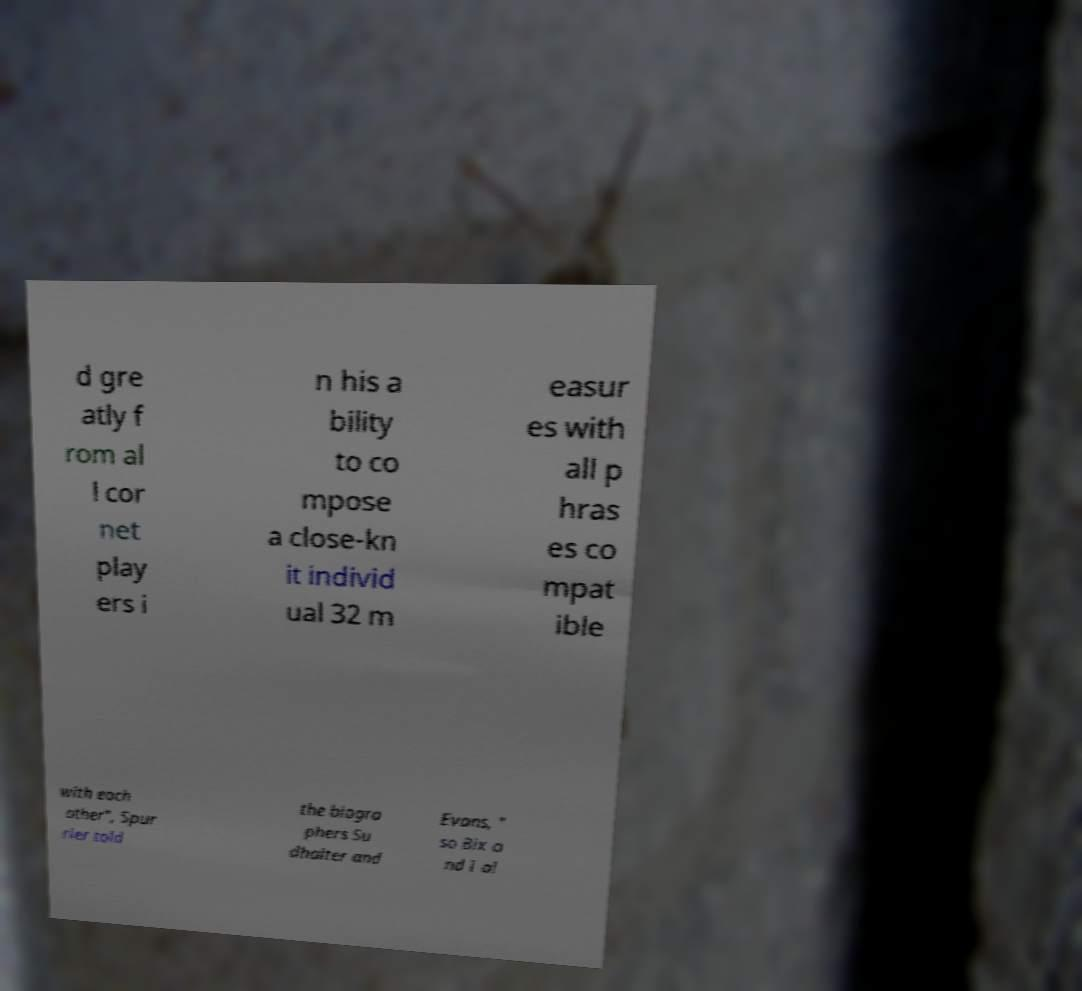Could you assist in decoding the text presented in this image and type it out clearly? d gre atly f rom al l cor net play ers i n his a bility to co mpose a close-kn it individ ual 32 m easur es with all p hras es co mpat ible with each other", Spur rier told the biogra phers Su dhalter and Evans, " so Bix a nd I al 